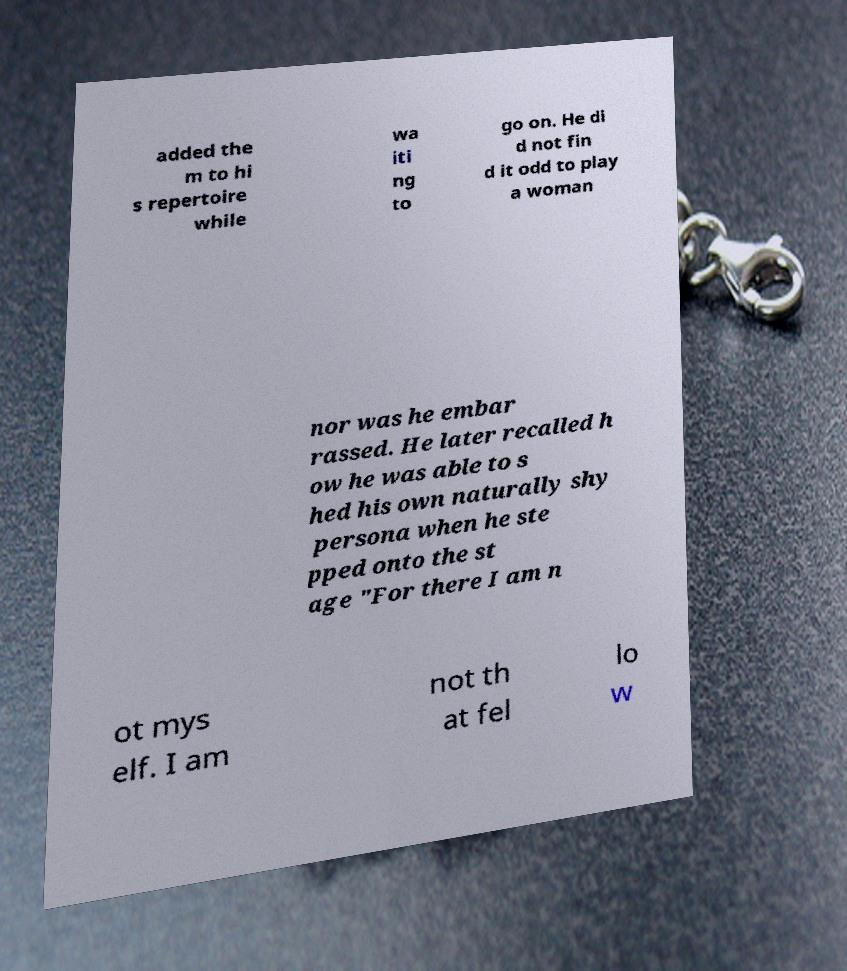Could you extract and type out the text from this image? added the m to hi s repertoire while wa iti ng to go on. He di d not fin d it odd to play a woman nor was he embar rassed. He later recalled h ow he was able to s hed his own naturally shy persona when he ste pped onto the st age "For there I am n ot mys elf. I am not th at fel lo w 